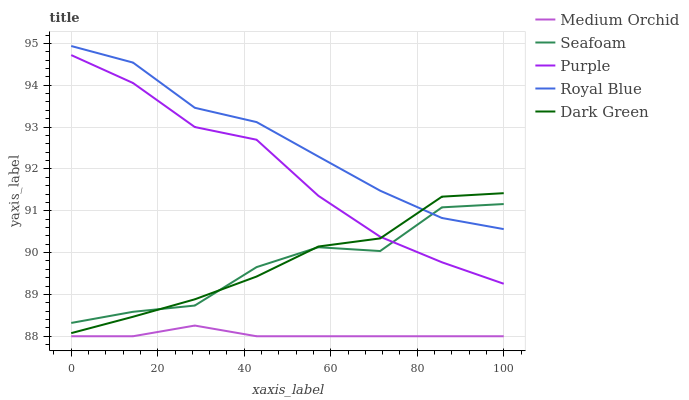Does Medium Orchid have the minimum area under the curve?
Answer yes or no. Yes. Does Royal Blue have the maximum area under the curve?
Answer yes or no. Yes. Does Royal Blue have the minimum area under the curve?
Answer yes or no. No. Does Medium Orchid have the maximum area under the curve?
Answer yes or no. No. Is Medium Orchid the smoothest?
Answer yes or no. Yes. Is Seafoam the roughest?
Answer yes or no. Yes. Is Royal Blue the smoothest?
Answer yes or no. No. Is Royal Blue the roughest?
Answer yes or no. No. Does Medium Orchid have the lowest value?
Answer yes or no. Yes. Does Royal Blue have the lowest value?
Answer yes or no. No. Does Royal Blue have the highest value?
Answer yes or no. Yes. Does Medium Orchid have the highest value?
Answer yes or no. No. Is Medium Orchid less than Seafoam?
Answer yes or no. Yes. Is Royal Blue greater than Medium Orchid?
Answer yes or no. Yes. Does Purple intersect Dark Green?
Answer yes or no. Yes. Is Purple less than Dark Green?
Answer yes or no. No. Is Purple greater than Dark Green?
Answer yes or no. No. Does Medium Orchid intersect Seafoam?
Answer yes or no. No. 